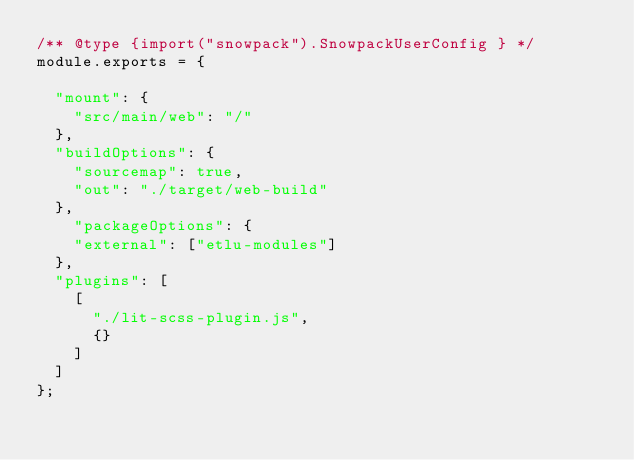Convert code to text. <code><loc_0><loc_0><loc_500><loc_500><_JavaScript_>/** @type {import("snowpack").SnowpackUserConfig } */
module.exports = {

  "mount": {
    "src/main/web": "/"
  },
  "buildOptions": {
    "sourcemap": true,
    "out": "./target/web-build"
  },
    "packageOptions": {
  	"external": ["etlu-modules"]
  },
  "plugins": [
    [
      "./lit-scss-plugin.js",
      {}
    ]
  ]
};
</code> 